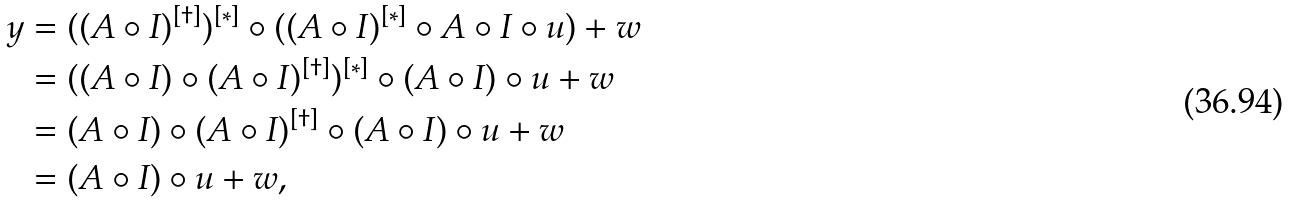Convert formula to latex. <formula><loc_0><loc_0><loc_500><loc_500>y & = ( ( A \circ I ) ^ { [ \dagger ] } ) ^ { [ * ] } \circ ( ( A \circ I ) ^ { [ * ] } \circ A \circ I \circ u ) + w \\ & = ( ( A \circ I ) \circ ( A \circ I ) ^ { [ \dagger ] } ) ^ { [ * ] } \circ ( A \circ I ) \circ u + w \\ & = ( A \circ I ) \circ ( A \circ I ) ^ { [ \dagger ] } \circ ( A \circ I ) \circ u + w \\ & = ( A \circ I ) \circ u + w ,</formula> 